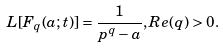<formula> <loc_0><loc_0><loc_500><loc_500>L [ F _ { q } ( a ; t ) ] = \frac { 1 } { p ^ { q } - a } , R e ( q ) > 0 .</formula> 